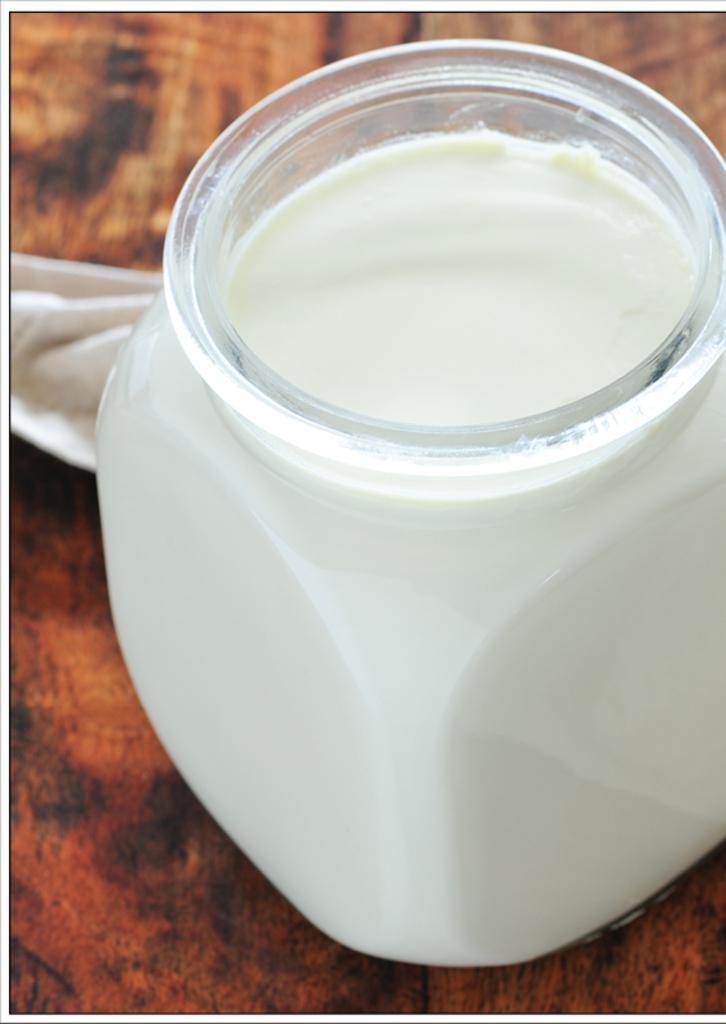What object is present in the image that is used for storing items? There is a glass jar in the image. What can be observed about the contents of the jar? The contents of the jar are white in color. On what surface is the jar placed in the image? The jar is on a brown-colored table. How many pears are on the table next to the jar in the image? There are no pears present in the image; only the glass jar and its white contents are visible. 